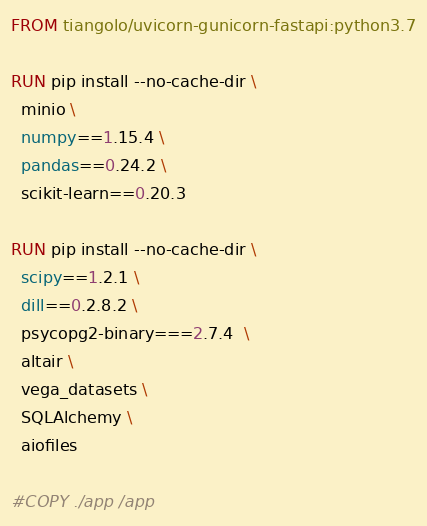Convert code to text. <code><loc_0><loc_0><loc_500><loc_500><_Dockerfile_>FROM tiangolo/uvicorn-gunicorn-fastapi:python3.7

RUN pip install --no-cache-dir \
  minio \
  numpy==1.15.4 \
  pandas==0.24.2 \
  scikit-learn==0.20.3 
  
RUN pip install --no-cache-dir \
  scipy==1.2.1 \
  dill==0.2.8.2 \
  psycopg2-binary===2.7.4  \
  altair \
  vega_datasets \
  SQLAlchemy \
  aiofiles

#COPY ./app /app</code> 